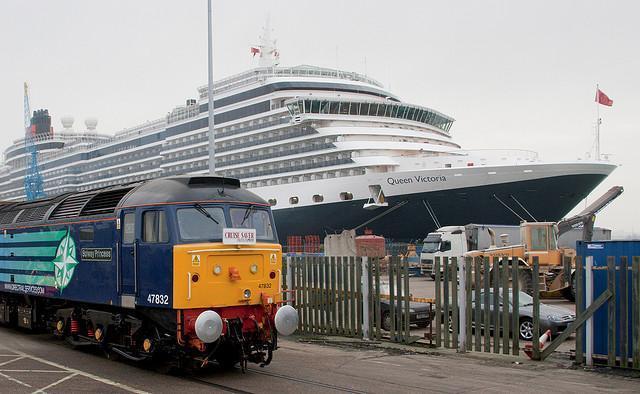The train is parked near what type of body of water?
Choose the correct response and explain in the format: 'Answer: answer
Rationale: rationale.'
Options: Sea, lake, marsh, river. Answer: sea.
Rationale: There is a large ocean. 